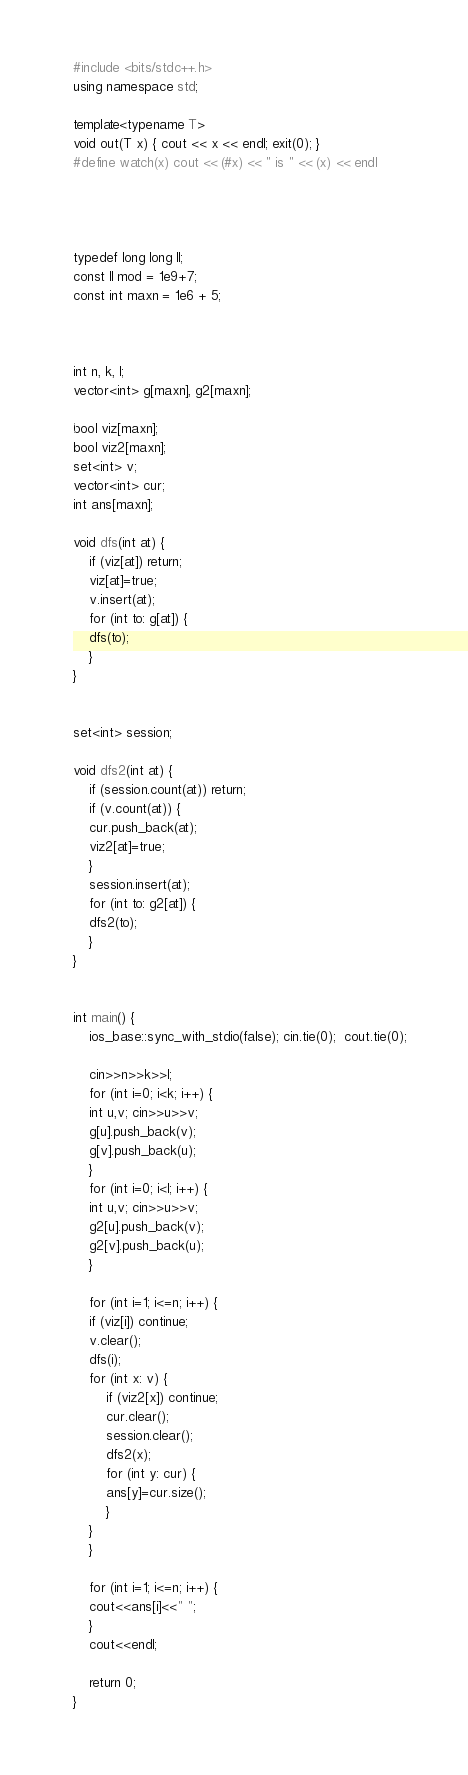Convert code to text. <code><loc_0><loc_0><loc_500><loc_500><_C++_>#include <bits/stdc++.h>
using namespace std;

template<typename T>
void out(T x) { cout << x << endl; exit(0); }
#define watch(x) cout << (#x) << " is " << (x) << endl




typedef long long ll;
const ll mod = 1e9+7;
const int maxn = 1e6 + 5;



int n, k, l;
vector<int> g[maxn], g2[maxn];

bool viz[maxn];
bool viz2[maxn];
set<int> v;
vector<int> cur;
int ans[maxn];

void dfs(int at) {
    if (viz[at]) return;
    viz[at]=true;
    v.insert(at);
    for (int to: g[at]) {
	dfs(to);
    }
}


set<int> session;

void dfs2(int at) {
    if (session.count(at)) return;
    if (v.count(at)) {
	cur.push_back(at);
	viz2[at]=true;
    }
    session.insert(at);
    for (int to: g2[at]) {
	dfs2(to);
    }
}


int main() {
    ios_base::sync_with_stdio(false); cin.tie(0);  cout.tie(0);

    cin>>n>>k>>l;
    for (int i=0; i<k; i++) {
	int u,v; cin>>u>>v;
	g[u].push_back(v);
	g[v].push_back(u);
    }
    for (int i=0; i<l; i++) {
	int u,v; cin>>u>>v;
	g2[u].push_back(v);
	g2[v].push_back(u);
    }

    for (int i=1; i<=n; i++) {
	if (viz[i]) continue;
	v.clear();
	dfs(i);
	for (int x: v) {
	    if (viz2[x]) continue;
	    cur.clear();
	    session.clear();
	    dfs2(x);
	    for (int y: cur) {
		ans[y]=cur.size();
	    }
	}
    }

    for (int i=1; i<=n; i++) {
	cout<<ans[i]<<" ";
    }
    cout<<endl;

    return 0;
}
</code> 